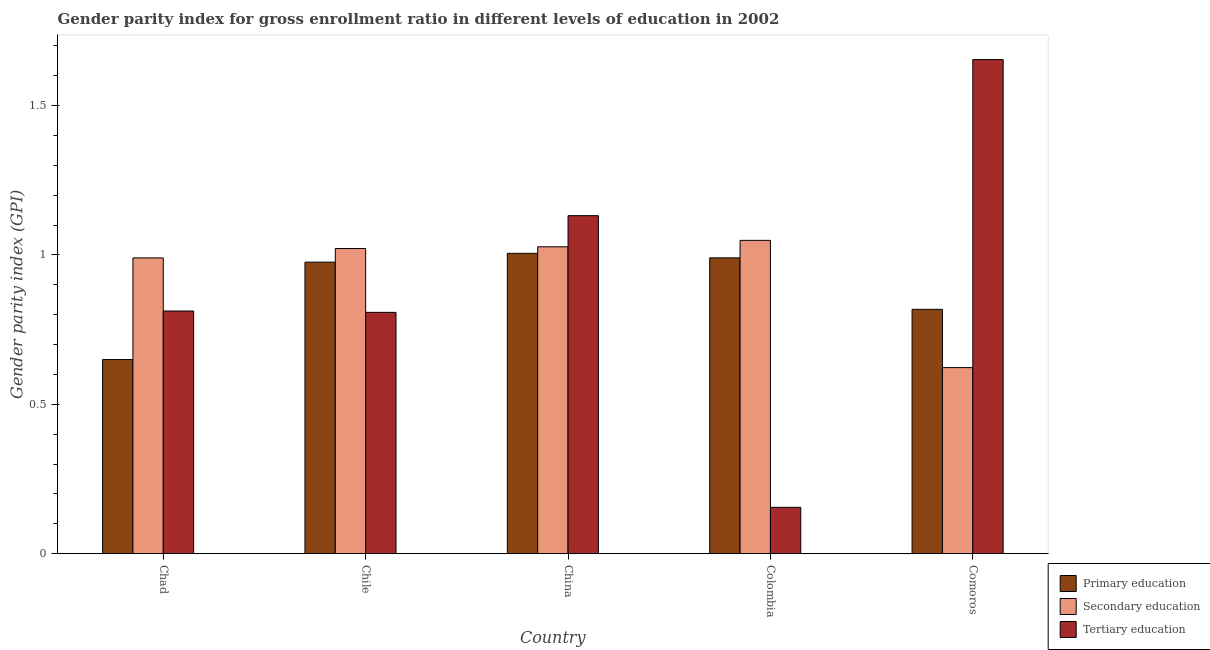Are the number of bars on each tick of the X-axis equal?
Your answer should be very brief. Yes. How many bars are there on the 1st tick from the right?
Make the answer very short. 3. What is the label of the 1st group of bars from the left?
Give a very brief answer. Chad. What is the gender parity index in secondary education in Chad?
Ensure brevity in your answer.  0.99. Across all countries, what is the maximum gender parity index in primary education?
Provide a succinct answer. 1.01. Across all countries, what is the minimum gender parity index in tertiary education?
Provide a short and direct response. 0.16. In which country was the gender parity index in primary education maximum?
Provide a short and direct response. China. What is the total gender parity index in tertiary education in the graph?
Make the answer very short. 4.56. What is the difference between the gender parity index in secondary education in Chad and that in China?
Offer a terse response. -0.04. What is the difference between the gender parity index in secondary education in China and the gender parity index in primary education in Chad?
Provide a short and direct response. 0.38. What is the average gender parity index in tertiary education per country?
Keep it short and to the point. 0.91. What is the difference between the gender parity index in tertiary education and gender parity index in primary education in Chad?
Your answer should be very brief. 0.16. In how many countries, is the gender parity index in primary education greater than 0.7 ?
Give a very brief answer. 4. What is the ratio of the gender parity index in secondary education in China to that in Colombia?
Offer a terse response. 0.98. Is the gender parity index in primary education in China less than that in Colombia?
Your answer should be compact. No. Is the difference between the gender parity index in tertiary education in Chad and Comoros greater than the difference between the gender parity index in primary education in Chad and Comoros?
Offer a terse response. No. What is the difference between the highest and the second highest gender parity index in primary education?
Your answer should be very brief. 0.02. What is the difference between the highest and the lowest gender parity index in tertiary education?
Your response must be concise. 1.5. Is the sum of the gender parity index in primary education in China and Colombia greater than the maximum gender parity index in tertiary education across all countries?
Ensure brevity in your answer.  Yes. What does the 2nd bar from the left in Chad represents?
Your answer should be compact. Secondary education. What does the 2nd bar from the right in Chile represents?
Provide a succinct answer. Secondary education. Is it the case that in every country, the sum of the gender parity index in primary education and gender parity index in secondary education is greater than the gender parity index in tertiary education?
Ensure brevity in your answer.  No. How many countries are there in the graph?
Offer a terse response. 5. Does the graph contain any zero values?
Offer a very short reply. No. Does the graph contain grids?
Ensure brevity in your answer.  No. How many legend labels are there?
Make the answer very short. 3. How are the legend labels stacked?
Provide a short and direct response. Vertical. What is the title of the graph?
Offer a very short reply. Gender parity index for gross enrollment ratio in different levels of education in 2002. What is the label or title of the X-axis?
Your response must be concise. Country. What is the label or title of the Y-axis?
Ensure brevity in your answer.  Gender parity index (GPI). What is the Gender parity index (GPI) in Primary education in Chad?
Keep it short and to the point. 0.65. What is the Gender parity index (GPI) of Secondary education in Chad?
Your response must be concise. 0.99. What is the Gender parity index (GPI) in Tertiary education in Chad?
Keep it short and to the point. 0.81. What is the Gender parity index (GPI) in Primary education in Chile?
Provide a short and direct response. 0.98. What is the Gender parity index (GPI) in Secondary education in Chile?
Your answer should be very brief. 1.02. What is the Gender parity index (GPI) of Tertiary education in Chile?
Make the answer very short. 0.81. What is the Gender parity index (GPI) in Primary education in China?
Ensure brevity in your answer.  1.01. What is the Gender parity index (GPI) of Secondary education in China?
Your answer should be very brief. 1.03. What is the Gender parity index (GPI) of Tertiary education in China?
Ensure brevity in your answer.  1.13. What is the Gender parity index (GPI) of Primary education in Colombia?
Keep it short and to the point. 0.99. What is the Gender parity index (GPI) in Secondary education in Colombia?
Make the answer very short. 1.05. What is the Gender parity index (GPI) of Tertiary education in Colombia?
Your answer should be compact. 0.16. What is the Gender parity index (GPI) of Primary education in Comoros?
Provide a short and direct response. 0.82. What is the Gender parity index (GPI) of Secondary education in Comoros?
Offer a very short reply. 0.62. What is the Gender parity index (GPI) of Tertiary education in Comoros?
Your answer should be very brief. 1.65. Across all countries, what is the maximum Gender parity index (GPI) in Primary education?
Provide a short and direct response. 1.01. Across all countries, what is the maximum Gender parity index (GPI) in Secondary education?
Your answer should be compact. 1.05. Across all countries, what is the maximum Gender parity index (GPI) of Tertiary education?
Keep it short and to the point. 1.65. Across all countries, what is the minimum Gender parity index (GPI) of Primary education?
Offer a terse response. 0.65. Across all countries, what is the minimum Gender parity index (GPI) of Secondary education?
Your answer should be very brief. 0.62. Across all countries, what is the minimum Gender parity index (GPI) in Tertiary education?
Ensure brevity in your answer.  0.16. What is the total Gender parity index (GPI) of Primary education in the graph?
Provide a succinct answer. 4.44. What is the total Gender parity index (GPI) of Secondary education in the graph?
Keep it short and to the point. 4.71. What is the total Gender parity index (GPI) in Tertiary education in the graph?
Offer a very short reply. 4.56. What is the difference between the Gender parity index (GPI) in Primary education in Chad and that in Chile?
Give a very brief answer. -0.33. What is the difference between the Gender parity index (GPI) in Secondary education in Chad and that in Chile?
Offer a very short reply. -0.03. What is the difference between the Gender parity index (GPI) in Tertiary education in Chad and that in Chile?
Provide a short and direct response. 0. What is the difference between the Gender parity index (GPI) of Primary education in Chad and that in China?
Offer a terse response. -0.36. What is the difference between the Gender parity index (GPI) of Secondary education in Chad and that in China?
Offer a very short reply. -0.04. What is the difference between the Gender parity index (GPI) in Tertiary education in Chad and that in China?
Offer a terse response. -0.32. What is the difference between the Gender parity index (GPI) of Primary education in Chad and that in Colombia?
Ensure brevity in your answer.  -0.34. What is the difference between the Gender parity index (GPI) of Secondary education in Chad and that in Colombia?
Your response must be concise. -0.06. What is the difference between the Gender parity index (GPI) of Tertiary education in Chad and that in Colombia?
Provide a succinct answer. 0.66. What is the difference between the Gender parity index (GPI) of Primary education in Chad and that in Comoros?
Give a very brief answer. -0.17. What is the difference between the Gender parity index (GPI) in Secondary education in Chad and that in Comoros?
Offer a terse response. 0.37. What is the difference between the Gender parity index (GPI) in Tertiary education in Chad and that in Comoros?
Your answer should be compact. -0.84. What is the difference between the Gender parity index (GPI) of Primary education in Chile and that in China?
Offer a very short reply. -0.03. What is the difference between the Gender parity index (GPI) of Secondary education in Chile and that in China?
Provide a succinct answer. -0.01. What is the difference between the Gender parity index (GPI) in Tertiary education in Chile and that in China?
Make the answer very short. -0.32. What is the difference between the Gender parity index (GPI) of Primary education in Chile and that in Colombia?
Your answer should be compact. -0.01. What is the difference between the Gender parity index (GPI) in Secondary education in Chile and that in Colombia?
Ensure brevity in your answer.  -0.03. What is the difference between the Gender parity index (GPI) of Tertiary education in Chile and that in Colombia?
Provide a short and direct response. 0.65. What is the difference between the Gender parity index (GPI) in Primary education in Chile and that in Comoros?
Make the answer very short. 0.16. What is the difference between the Gender parity index (GPI) in Secondary education in Chile and that in Comoros?
Ensure brevity in your answer.  0.4. What is the difference between the Gender parity index (GPI) of Tertiary education in Chile and that in Comoros?
Your answer should be compact. -0.85. What is the difference between the Gender parity index (GPI) of Primary education in China and that in Colombia?
Offer a very short reply. 0.02. What is the difference between the Gender parity index (GPI) of Secondary education in China and that in Colombia?
Keep it short and to the point. -0.02. What is the difference between the Gender parity index (GPI) in Tertiary education in China and that in Colombia?
Your answer should be very brief. 0.98. What is the difference between the Gender parity index (GPI) in Primary education in China and that in Comoros?
Your response must be concise. 0.19. What is the difference between the Gender parity index (GPI) of Secondary education in China and that in Comoros?
Your answer should be very brief. 0.4. What is the difference between the Gender parity index (GPI) in Tertiary education in China and that in Comoros?
Offer a very short reply. -0.52. What is the difference between the Gender parity index (GPI) in Primary education in Colombia and that in Comoros?
Offer a terse response. 0.17. What is the difference between the Gender parity index (GPI) in Secondary education in Colombia and that in Comoros?
Your answer should be very brief. 0.43. What is the difference between the Gender parity index (GPI) in Tertiary education in Colombia and that in Comoros?
Your answer should be compact. -1.5. What is the difference between the Gender parity index (GPI) in Primary education in Chad and the Gender parity index (GPI) in Secondary education in Chile?
Provide a succinct answer. -0.37. What is the difference between the Gender parity index (GPI) in Primary education in Chad and the Gender parity index (GPI) in Tertiary education in Chile?
Keep it short and to the point. -0.16. What is the difference between the Gender parity index (GPI) in Secondary education in Chad and the Gender parity index (GPI) in Tertiary education in Chile?
Your answer should be very brief. 0.18. What is the difference between the Gender parity index (GPI) of Primary education in Chad and the Gender parity index (GPI) of Secondary education in China?
Your answer should be very brief. -0.38. What is the difference between the Gender parity index (GPI) in Primary education in Chad and the Gender parity index (GPI) in Tertiary education in China?
Keep it short and to the point. -0.48. What is the difference between the Gender parity index (GPI) in Secondary education in Chad and the Gender parity index (GPI) in Tertiary education in China?
Offer a terse response. -0.14. What is the difference between the Gender parity index (GPI) of Primary education in Chad and the Gender parity index (GPI) of Secondary education in Colombia?
Offer a very short reply. -0.4. What is the difference between the Gender parity index (GPI) in Primary education in Chad and the Gender parity index (GPI) in Tertiary education in Colombia?
Provide a succinct answer. 0.49. What is the difference between the Gender parity index (GPI) in Secondary education in Chad and the Gender parity index (GPI) in Tertiary education in Colombia?
Provide a short and direct response. 0.83. What is the difference between the Gender parity index (GPI) of Primary education in Chad and the Gender parity index (GPI) of Secondary education in Comoros?
Ensure brevity in your answer.  0.03. What is the difference between the Gender parity index (GPI) in Primary education in Chad and the Gender parity index (GPI) in Tertiary education in Comoros?
Provide a succinct answer. -1. What is the difference between the Gender parity index (GPI) of Secondary education in Chad and the Gender parity index (GPI) of Tertiary education in Comoros?
Offer a very short reply. -0.66. What is the difference between the Gender parity index (GPI) of Primary education in Chile and the Gender parity index (GPI) of Secondary education in China?
Your answer should be compact. -0.05. What is the difference between the Gender parity index (GPI) of Primary education in Chile and the Gender parity index (GPI) of Tertiary education in China?
Give a very brief answer. -0.16. What is the difference between the Gender parity index (GPI) in Secondary education in Chile and the Gender parity index (GPI) in Tertiary education in China?
Give a very brief answer. -0.11. What is the difference between the Gender parity index (GPI) of Primary education in Chile and the Gender parity index (GPI) of Secondary education in Colombia?
Provide a succinct answer. -0.07. What is the difference between the Gender parity index (GPI) of Primary education in Chile and the Gender parity index (GPI) of Tertiary education in Colombia?
Offer a terse response. 0.82. What is the difference between the Gender parity index (GPI) of Secondary education in Chile and the Gender parity index (GPI) of Tertiary education in Colombia?
Provide a succinct answer. 0.87. What is the difference between the Gender parity index (GPI) in Primary education in Chile and the Gender parity index (GPI) in Secondary education in Comoros?
Your answer should be very brief. 0.35. What is the difference between the Gender parity index (GPI) of Primary education in Chile and the Gender parity index (GPI) of Tertiary education in Comoros?
Provide a succinct answer. -0.68. What is the difference between the Gender parity index (GPI) in Secondary education in Chile and the Gender parity index (GPI) in Tertiary education in Comoros?
Provide a short and direct response. -0.63. What is the difference between the Gender parity index (GPI) of Primary education in China and the Gender parity index (GPI) of Secondary education in Colombia?
Your answer should be compact. -0.04. What is the difference between the Gender parity index (GPI) in Primary education in China and the Gender parity index (GPI) in Tertiary education in Colombia?
Provide a succinct answer. 0.85. What is the difference between the Gender parity index (GPI) of Secondary education in China and the Gender parity index (GPI) of Tertiary education in Colombia?
Your answer should be very brief. 0.87. What is the difference between the Gender parity index (GPI) of Primary education in China and the Gender parity index (GPI) of Secondary education in Comoros?
Make the answer very short. 0.38. What is the difference between the Gender parity index (GPI) of Primary education in China and the Gender parity index (GPI) of Tertiary education in Comoros?
Ensure brevity in your answer.  -0.65. What is the difference between the Gender parity index (GPI) in Secondary education in China and the Gender parity index (GPI) in Tertiary education in Comoros?
Give a very brief answer. -0.63. What is the difference between the Gender parity index (GPI) of Primary education in Colombia and the Gender parity index (GPI) of Secondary education in Comoros?
Your answer should be very brief. 0.37. What is the difference between the Gender parity index (GPI) of Primary education in Colombia and the Gender parity index (GPI) of Tertiary education in Comoros?
Provide a short and direct response. -0.66. What is the difference between the Gender parity index (GPI) of Secondary education in Colombia and the Gender parity index (GPI) of Tertiary education in Comoros?
Keep it short and to the point. -0.61. What is the average Gender parity index (GPI) of Primary education per country?
Provide a short and direct response. 0.89. What is the average Gender parity index (GPI) of Secondary education per country?
Offer a very short reply. 0.94. What is the average Gender parity index (GPI) of Tertiary education per country?
Ensure brevity in your answer.  0.91. What is the difference between the Gender parity index (GPI) in Primary education and Gender parity index (GPI) in Secondary education in Chad?
Offer a very short reply. -0.34. What is the difference between the Gender parity index (GPI) of Primary education and Gender parity index (GPI) of Tertiary education in Chad?
Keep it short and to the point. -0.16. What is the difference between the Gender parity index (GPI) in Secondary education and Gender parity index (GPI) in Tertiary education in Chad?
Provide a succinct answer. 0.18. What is the difference between the Gender parity index (GPI) of Primary education and Gender parity index (GPI) of Secondary education in Chile?
Keep it short and to the point. -0.05. What is the difference between the Gender parity index (GPI) in Primary education and Gender parity index (GPI) in Tertiary education in Chile?
Your answer should be very brief. 0.17. What is the difference between the Gender parity index (GPI) in Secondary education and Gender parity index (GPI) in Tertiary education in Chile?
Provide a short and direct response. 0.21. What is the difference between the Gender parity index (GPI) of Primary education and Gender parity index (GPI) of Secondary education in China?
Ensure brevity in your answer.  -0.02. What is the difference between the Gender parity index (GPI) of Primary education and Gender parity index (GPI) of Tertiary education in China?
Your answer should be compact. -0.13. What is the difference between the Gender parity index (GPI) in Secondary education and Gender parity index (GPI) in Tertiary education in China?
Make the answer very short. -0.1. What is the difference between the Gender parity index (GPI) in Primary education and Gender parity index (GPI) in Secondary education in Colombia?
Provide a short and direct response. -0.06. What is the difference between the Gender parity index (GPI) of Primary education and Gender parity index (GPI) of Tertiary education in Colombia?
Give a very brief answer. 0.83. What is the difference between the Gender parity index (GPI) in Secondary education and Gender parity index (GPI) in Tertiary education in Colombia?
Ensure brevity in your answer.  0.89. What is the difference between the Gender parity index (GPI) of Primary education and Gender parity index (GPI) of Secondary education in Comoros?
Your response must be concise. 0.2. What is the difference between the Gender parity index (GPI) in Primary education and Gender parity index (GPI) in Tertiary education in Comoros?
Ensure brevity in your answer.  -0.84. What is the difference between the Gender parity index (GPI) in Secondary education and Gender parity index (GPI) in Tertiary education in Comoros?
Ensure brevity in your answer.  -1.03. What is the ratio of the Gender parity index (GPI) of Primary education in Chad to that in Chile?
Make the answer very short. 0.67. What is the ratio of the Gender parity index (GPI) in Secondary education in Chad to that in Chile?
Keep it short and to the point. 0.97. What is the ratio of the Gender parity index (GPI) in Tertiary education in Chad to that in Chile?
Offer a very short reply. 1.01. What is the ratio of the Gender parity index (GPI) of Primary education in Chad to that in China?
Offer a terse response. 0.65. What is the ratio of the Gender parity index (GPI) in Secondary education in Chad to that in China?
Make the answer very short. 0.96. What is the ratio of the Gender parity index (GPI) in Tertiary education in Chad to that in China?
Provide a short and direct response. 0.72. What is the ratio of the Gender parity index (GPI) in Primary education in Chad to that in Colombia?
Ensure brevity in your answer.  0.66. What is the ratio of the Gender parity index (GPI) of Secondary education in Chad to that in Colombia?
Provide a short and direct response. 0.94. What is the ratio of the Gender parity index (GPI) in Tertiary education in Chad to that in Colombia?
Your answer should be compact. 5.23. What is the ratio of the Gender parity index (GPI) in Primary education in Chad to that in Comoros?
Your answer should be compact. 0.79. What is the ratio of the Gender parity index (GPI) of Secondary education in Chad to that in Comoros?
Your answer should be compact. 1.59. What is the ratio of the Gender parity index (GPI) in Tertiary education in Chad to that in Comoros?
Your response must be concise. 0.49. What is the ratio of the Gender parity index (GPI) of Primary education in Chile to that in China?
Your response must be concise. 0.97. What is the ratio of the Gender parity index (GPI) of Secondary education in Chile to that in China?
Ensure brevity in your answer.  0.99. What is the ratio of the Gender parity index (GPI) of Tertiary education in Chile to that in China?
Make the answer very short. 0.71. What is the ratio of the Gender parity index (GPI) in Primary education in Chile to that in Colombia?
Keep it short and to the point. 0.99. What is the ratio of the Gender parity index (GPI) in Secondary education in Chile to that in Colombia?
Your response must be concise. 0.97. What is the ratio of the Gender parity index (GPI) of Tertiary education in Chile to that in Colombia?
Provide a succinct answer. 5.2. What is the ratio of the Gender parity index (GPI) in Primary education in Chile to that in Comoros?
Provide a short and direct response. 1.19. What is the ratio of the Gender parity index (GPI) in Secondary education in Chile to that in Comoros?
Provide a short and direct response. 1.64. What is the ratio of the Gender parity index (GPI) of Tertiary education in Chile to that in Comoros?
Give a very brief answer. 0.49. What is the ratio of the Gender parity index (GPI) of Primary education in China to that in Colombia?
Your response must be concise. 1.02. What is the ratio of the Gender parity index (GPI) of Secondary education in China to that in Colombia?
Provide a short and direct response. 0.98. What is the ratio of the Gender parity index (GPI) in Tertiary education in China to that in Colombia?
Keep it short and to the point. 7.29. What is the ratio of the Gender parity index (GPI) in Primary education in China to that in Comoros?
Ensure brevity in your answer.  1.23. What is the ratio of the Gender parity index (GPI) of Secondary education in China to that in Comoros?
Offer a very short reply. 1.65. What is the ratio of the Gender parity index (GPI) in Tertiary education in China to that in Comoros?
Ensure brevity in your answer.  0.68. What is the ratio of the Gender parity index (GPI) of Primary education in Colombia to that in Comoros?
Your answer should be compact. 1.21. What is the ratio of the Gender parity index (GPI) of Secondary education in Colombia to that in Comoros?
Give a very brief answer. 1.68. What is the ratio of the Gender parity index (GPI) of Tertiary education in Colombia to that in Comoros?
Offer a very short reply. 0.09. What is the difference between the highest and the second highest Gender parity index (GPI) of Primary education?
Offer a very short reply. 0.02. What is the difference between the highest and the second highest Gender parity index (GPI) in Secondary education?
Your answer should be compact. 0.02. What is the difference between the highest and the second highest Gender parity index (GPI) of Tertiary education?
Your answer should be compact. 0.52. What is the difference between the highest and the lowest Gender parity index (GPI) of Primary education?
Offer a terse response. 0.36. What is the difference between the highest and the lowest Gender parity index (GPI) of Secondary education?
Offer a terse response. 0.43. What is the difference between the highest and the lowest Gender parity index (GPI) in Tertiary education?
Offer a terse response. 1.5. 